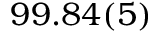<formula> <loc_0><loc_0><loc_500><loc_500>9 9 . 8 4 ( 5 ) \</formula> 